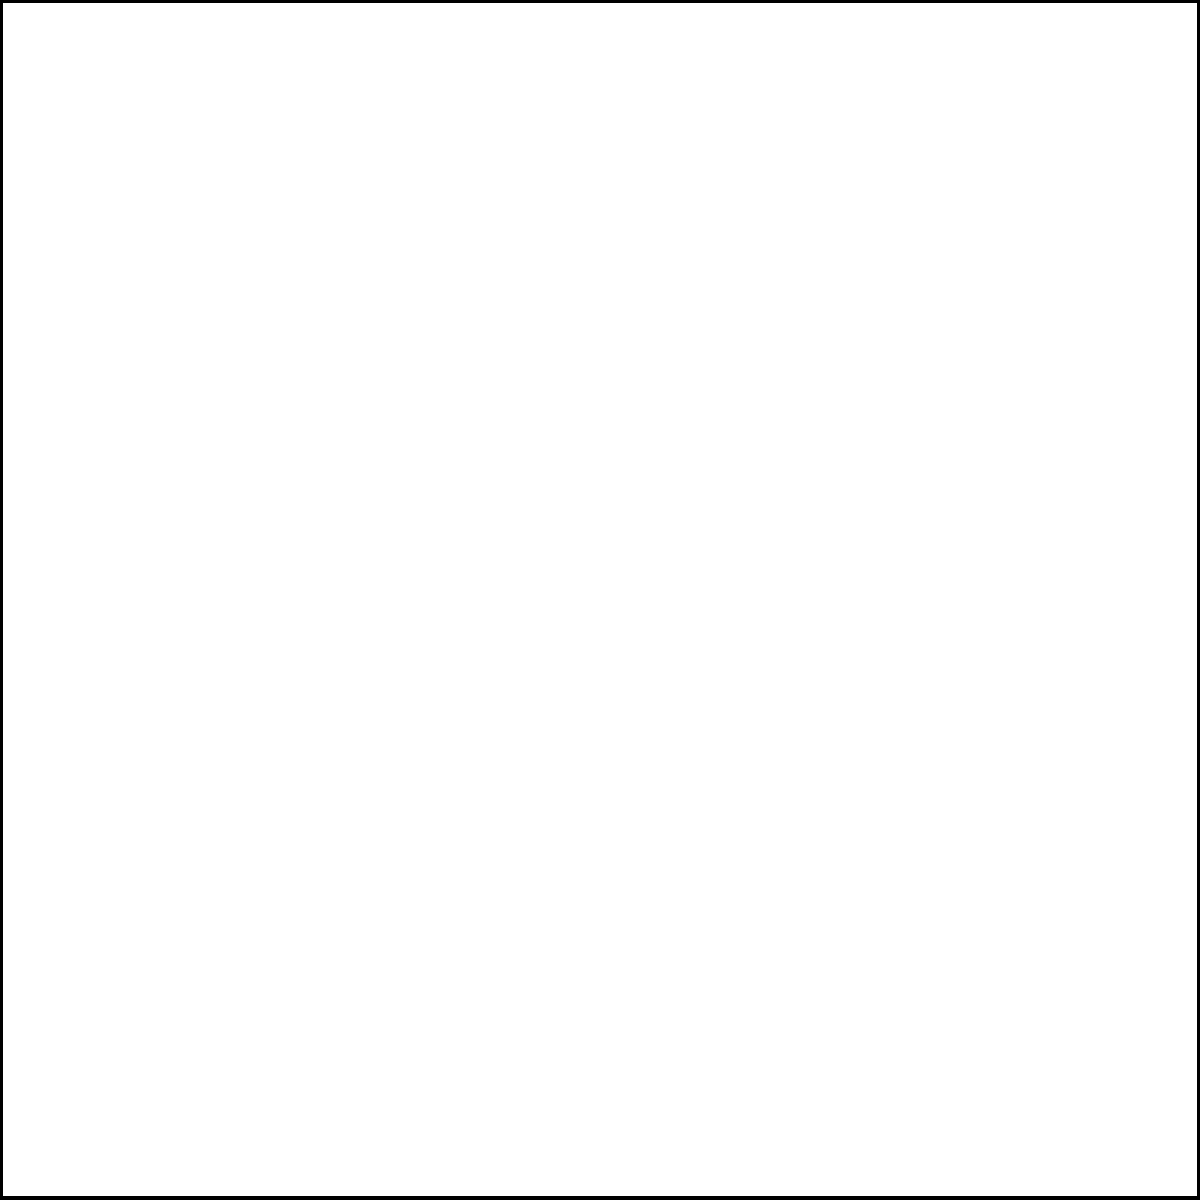In memory of your grandmother, you decide to create a circular garden within a square plot of land. The square plot has sides of length 4 meters. If you want the circular garden to touch all four sides of the square plot, what will be the area of the remaining land in the corners of the square plot? Round your answer to two decimal places. Let's approach this step-by-step:

1) First, we need to find the radius of the inscribed circle. In a square, the diameter of the inscribed circle is equal to the side length of the square. So:

   $d = 4$ meters
   $r = d/2 = 4/2 = 2$ meters

2) Now, we can calculate the areas:

   Area of the square: $A_s = s^2 = 4^2 = 16$ sq meters

   Area of the circle: $A_c = \pi r^2 = \pi (2^2) = 4\pi$ sq meters

3) The remaining area is the difference between these:

   $A_{remaining} = A_s - A_c = 16 - 4\pi$

4) Let's calculate this:

   $16 - 4\pi \approx 16 - 12.5664 = 3.4336$ sq meters

5) Rounding to two decimal places:

   $3.43$ sq meters

This represents the total area of the four corners outside the circular garden.
Answer: $3.43$ sq meters 